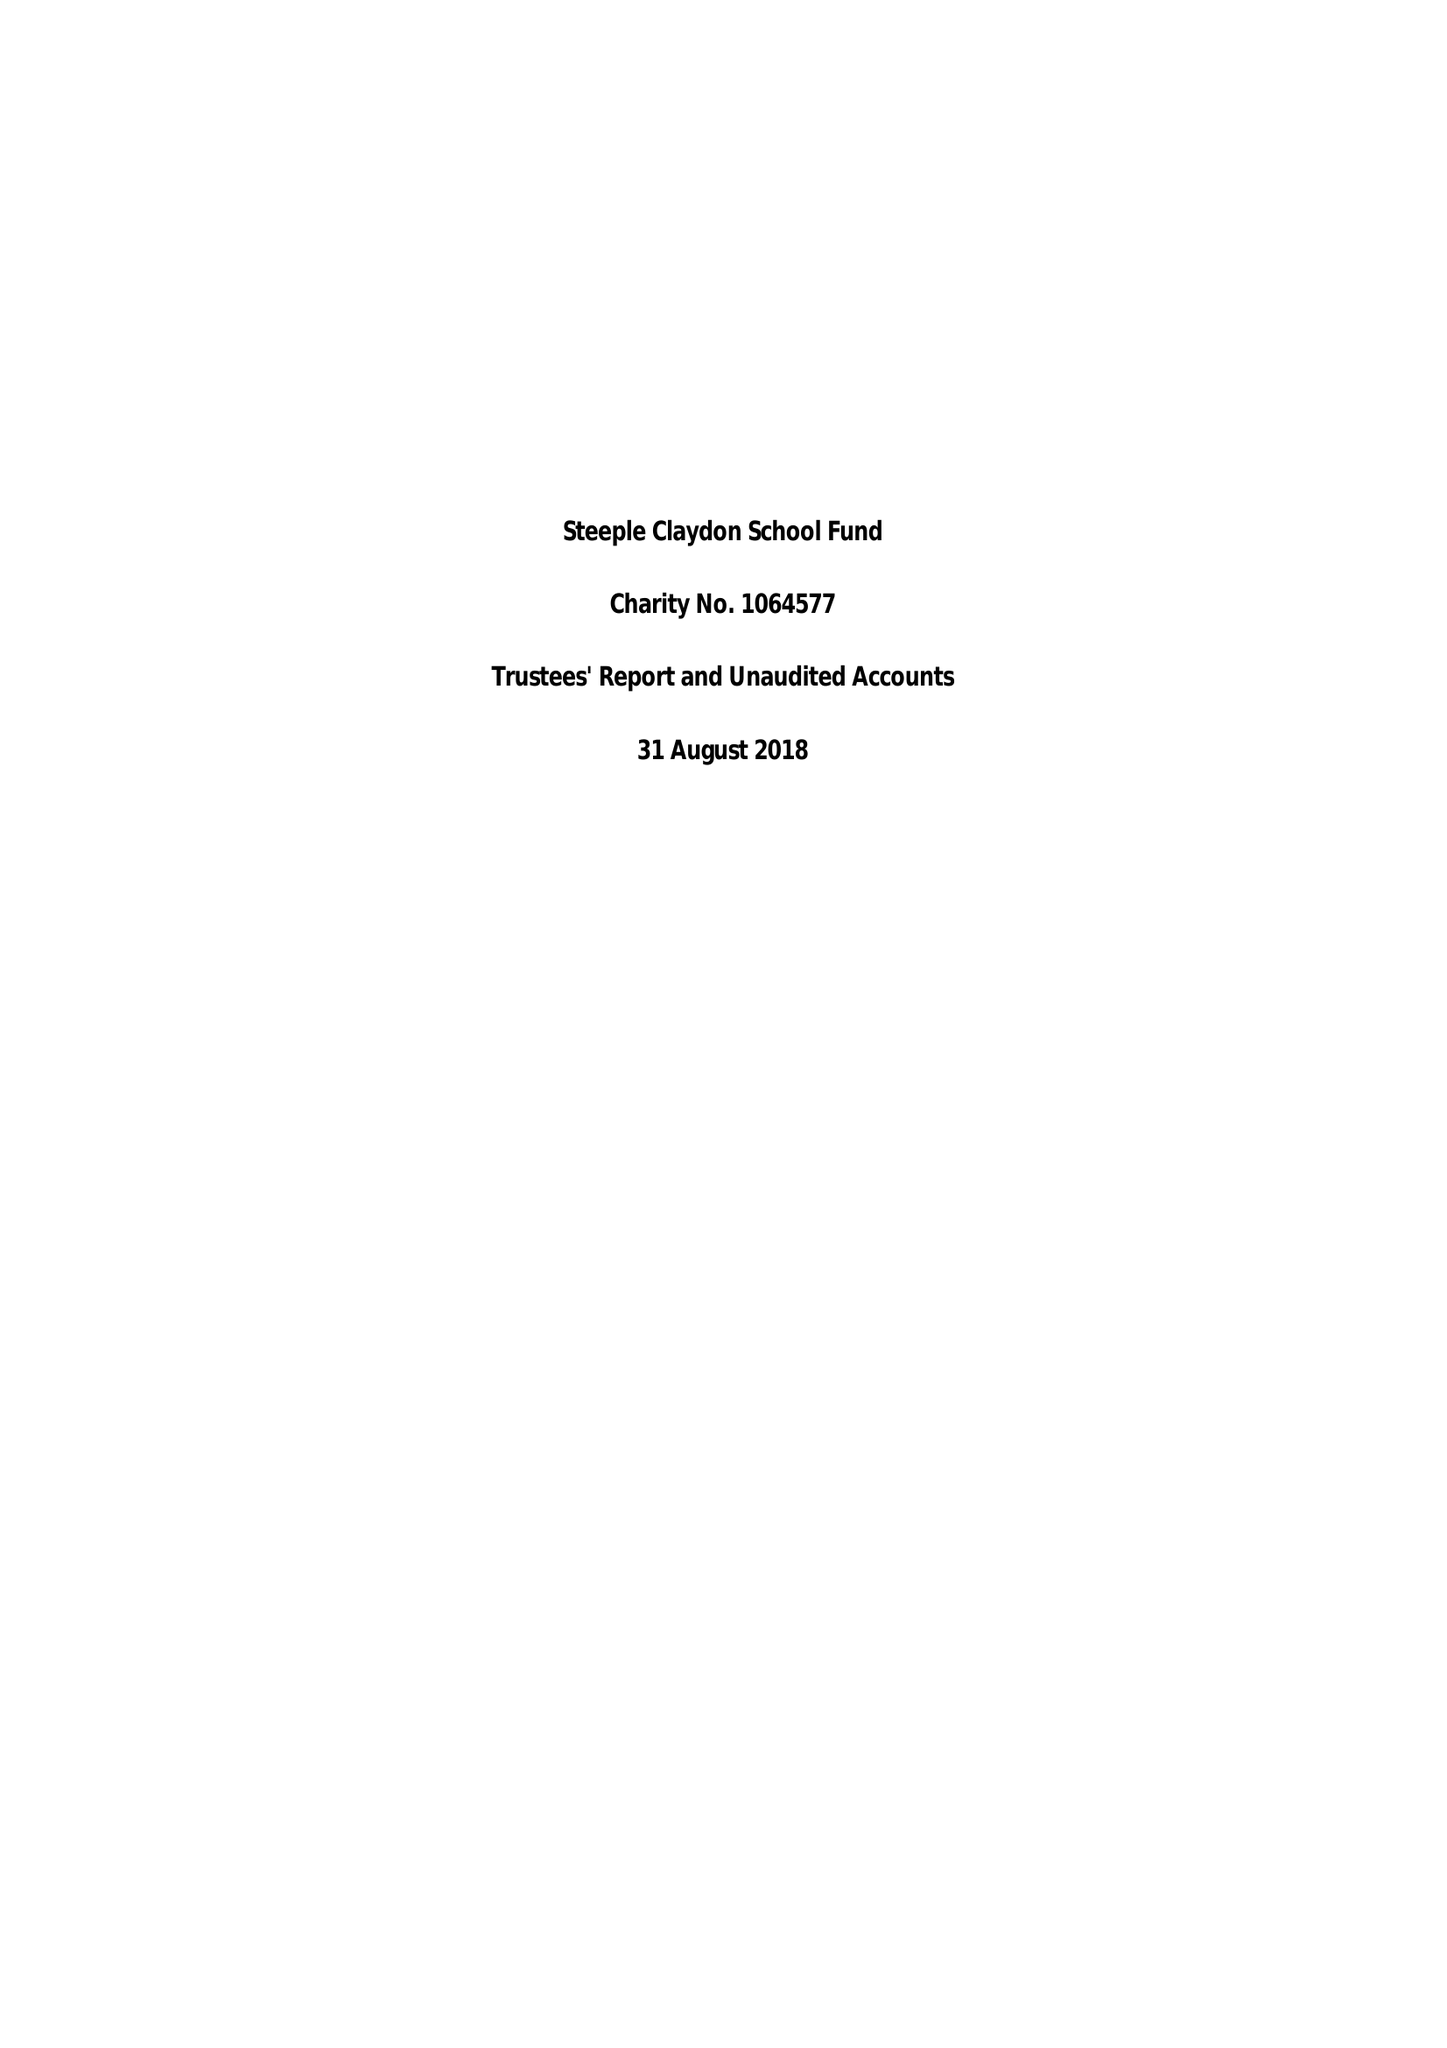What is the value for the report_date?
Answer the question using a single word or phrase. 2018-08-31 